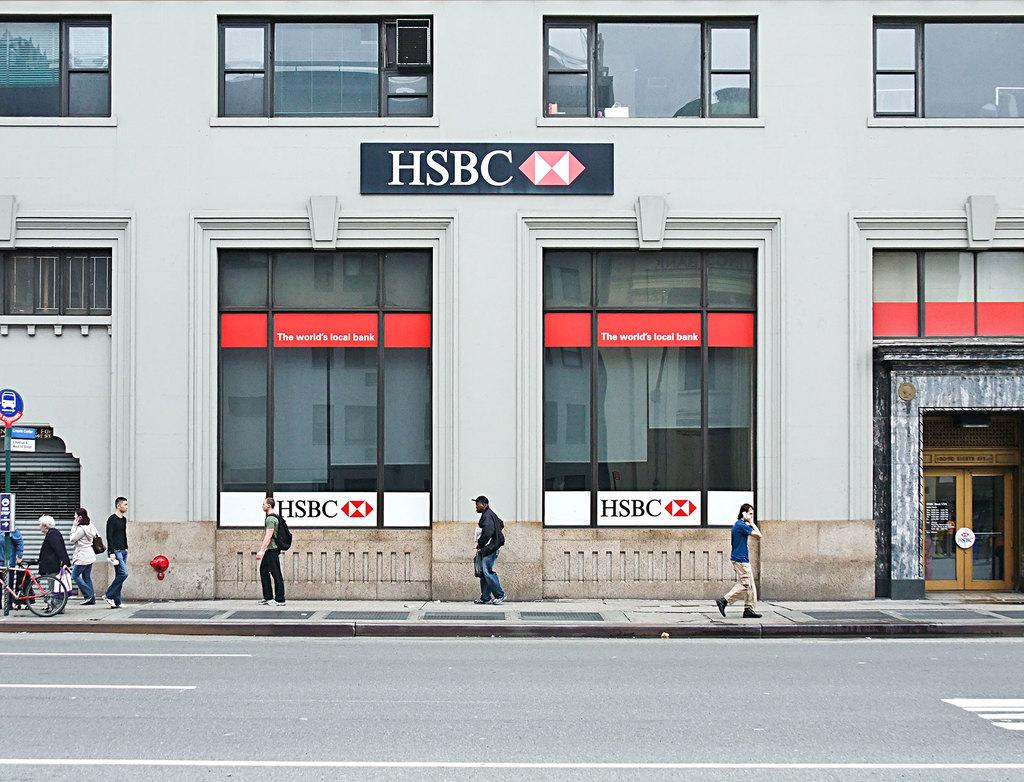<image>
Describe the image concisely. The front of a building with people walking in front and it has a sign on the windows that says HSBC on it. 